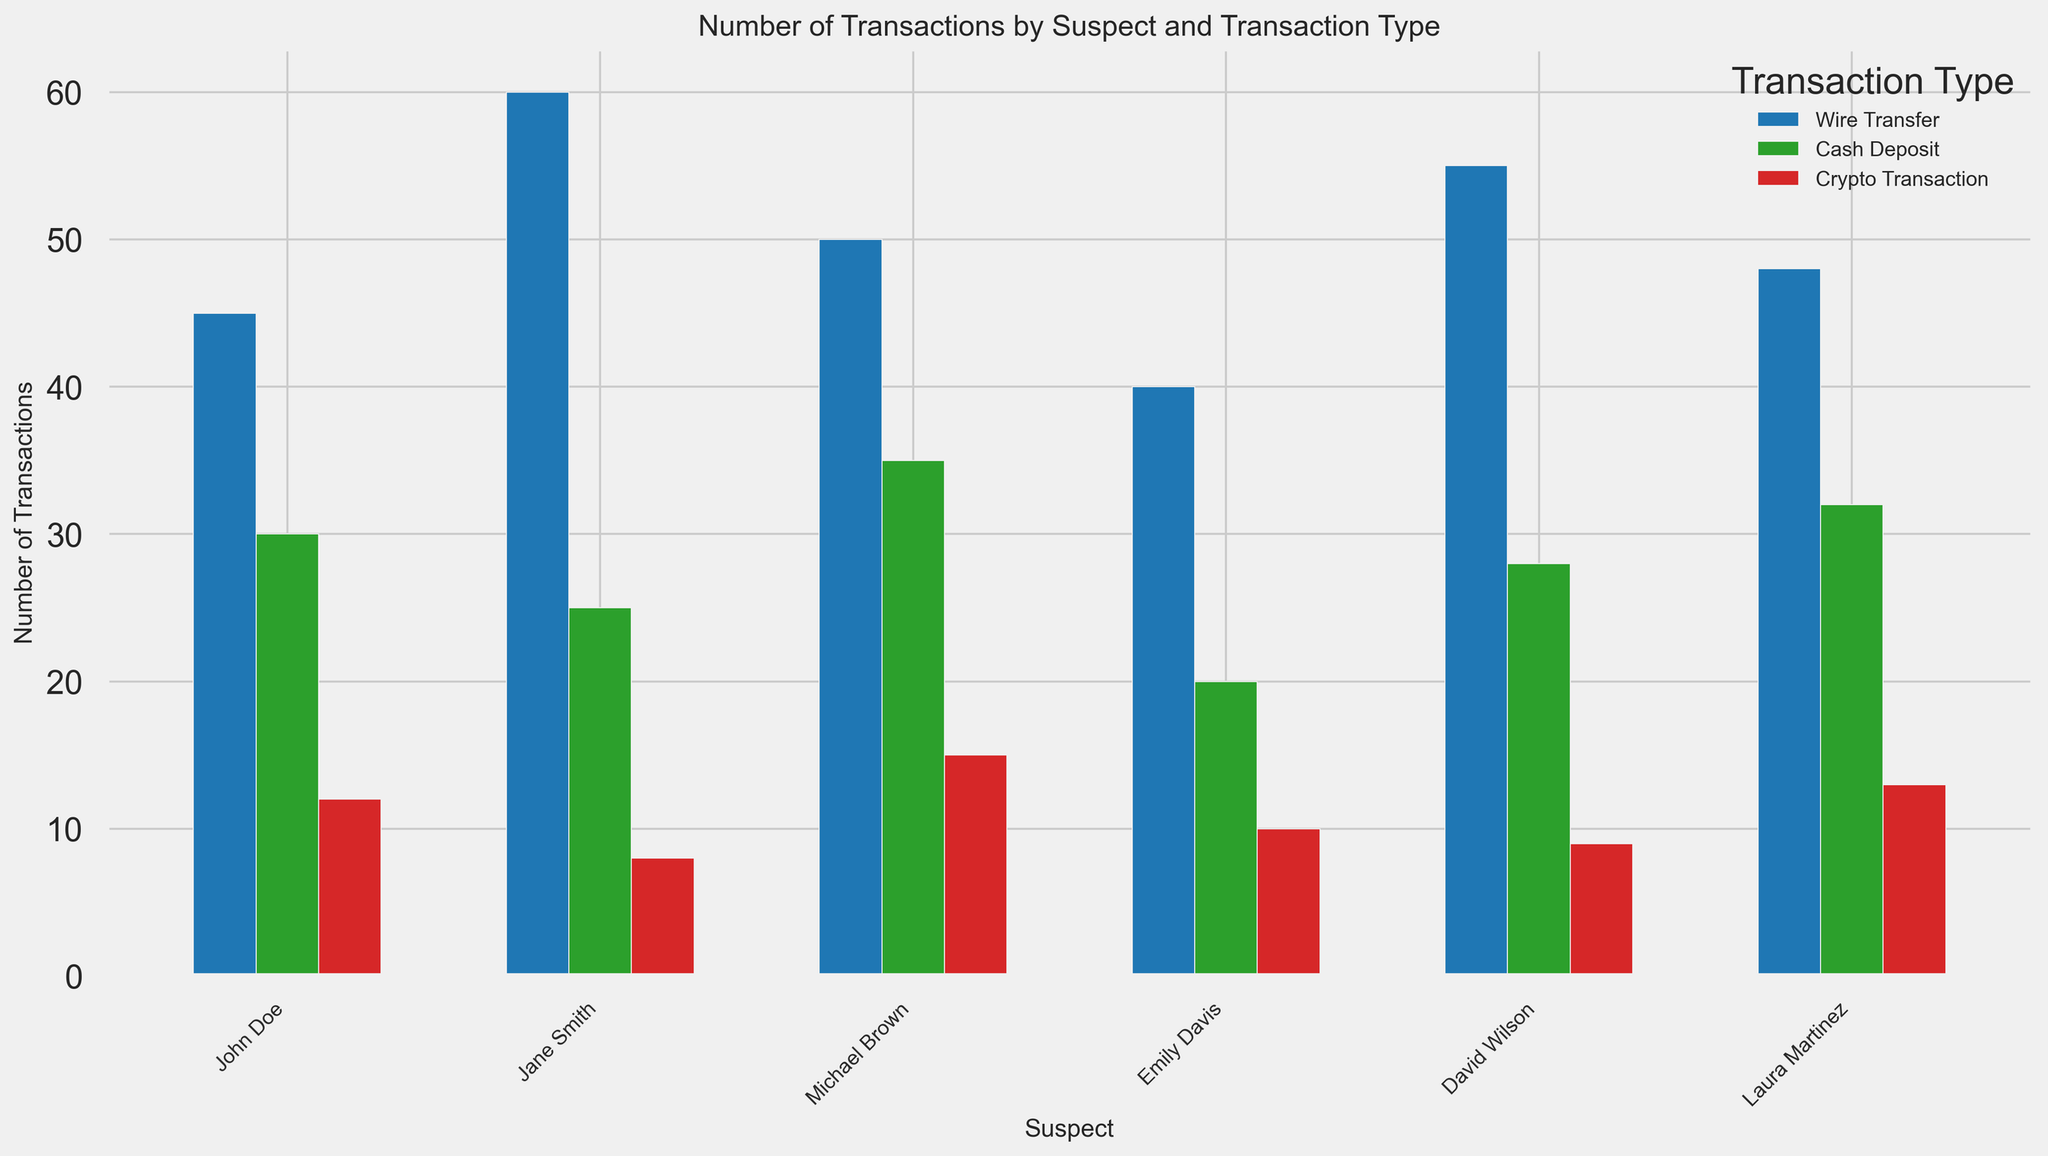Which suspect has the highest number of Wire Transfers? Look at the bars corresponding to the "Wire Transfer" transaction type. The highest bar in the "Wire Transfer" category belongs to Jane Smith.
Answer: Jane Smith Who performed more Crypto Transactions, Michael Brown or John Doe? Compare the heights of the "Crypto Transaction" bars for Michael Brown and John Doe. Michael Brown has a higher bar.
Answer: Michael Brown What is the total number of Cash Deposits for Emily Davis? Observe the height of the bar corresponding to "Cash Deposit" for Emily Davis. The value is 20.
Answer: 20 Which transaction type does John Doe perform the least of? Look at the three bars for John Doe and find the shortest one. The "Crypto Transaction" has the shortest bar with a value of 12.
Answer: Crypto Transaction Compare the total number of Wire Transfers for David Wilson and Laura Martinez. Who has more? Add up the number of Wire Transfers for both David Wilson (55) and Laura Martinez (48). David Wilson has more Wire Transfers.
Answer: David Wilson What is the sum of Cash Deposits by all suspects? Add up the number of Cash Deposits for each suspect (John Doe: 30, Jane Smith: 25, Michael Brown: 35, Emily Davis: 20, David Wilson: 28, Laura Martinez: 32). The total is (30 + 25 + 35 + 20 + 28 + 32 = 170).
Answer: 170 Which suspect has the least variation in the number of transactions across all transaction types? Visually assess which suspect has bars of nearly the same height across all three transaction types. Emily Davis seems to have the least variation, with values of 40, 20, and 10.
Answer: Emily Davis Who performed the most transactions overall? Sum the bars for each suspect and compare. Jane Smith has the highest total with 60 (Wire Transfer) + 25 (Cash Deposit) + 8 (Crypto Transaction) = 93.
Answer: Jane Smith 